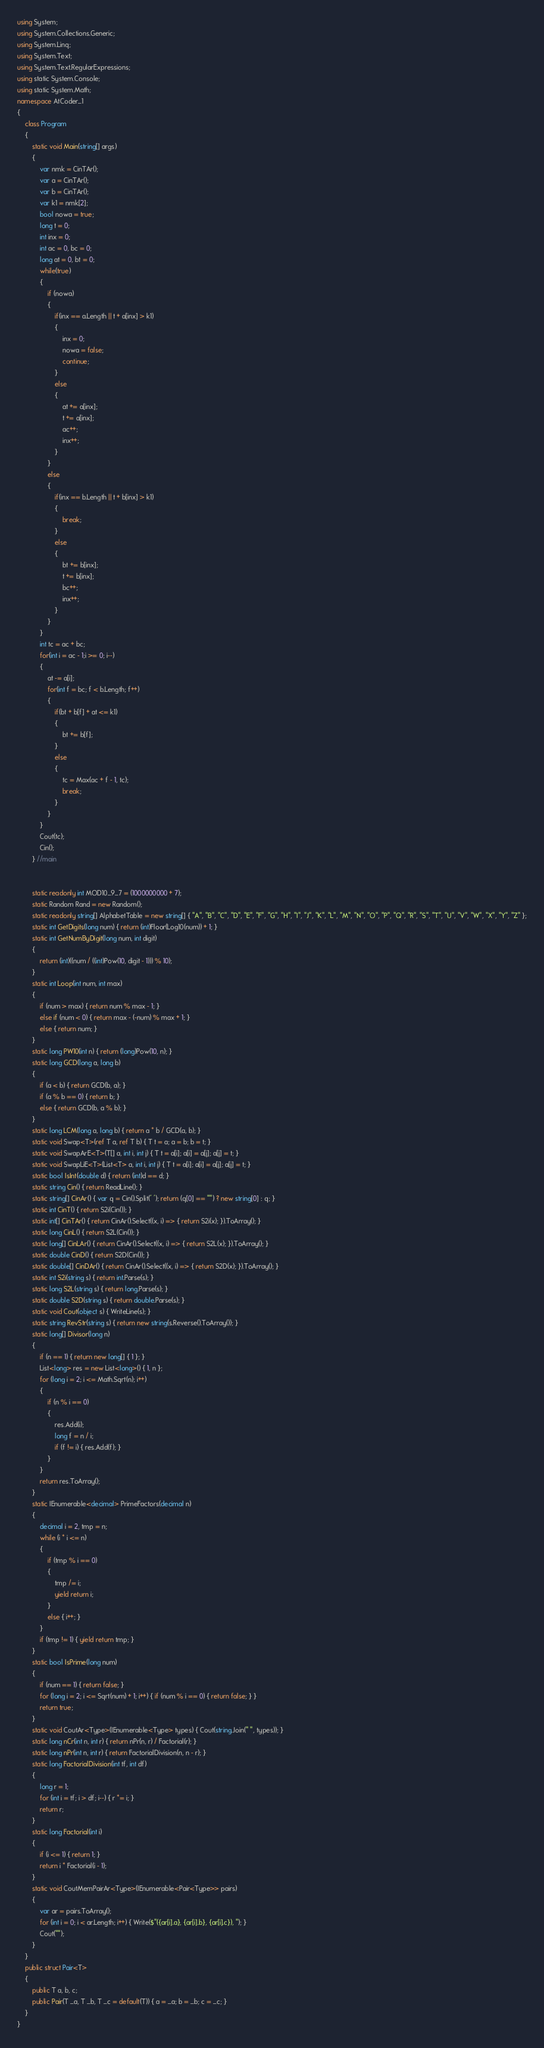Convert code to text. <code><loc_0><loc_0><loc_500><loc_500><_C#_>using System;
using System.Collections.Generic;
using System.Linq;
using System.Text;
using System.Text.RegularExpressions;
using static System.Console;
using static System.Math;
namespace AtCoder_1
{
    class Program
    {
        static void Main(string[] args)
        {
            var nmk = CinTAr();
            var a = CinTAr();
            var b = CinTAr();
            var k1 = nmk[2];
            bool nowa = true;
            long t = 0;
            int inx = 0;
            int ac = 0, bc = 0;
            long at = 0, bt = 0;
            while(true)
            {
                if (nowa)
                {
                    if(inx == a.Length || t + a[inx] > k1)
                    {
                        inx = 0;
                        nowa = false;
                        continue;
                    }
                    else
                    {
                        at += a[inx];
                        t += a[inx];
                        ac++;
                        inx++;
                    }
                }
                else
                {
                    if(inx == b.Length || t + b[inx] > k1)
                    {
                        break;
                    }
                    else
                    {
                        bt += b[inx];
                        t += b[inx];
                        bc++;
                        inx++;
                    }
                }
            }
            int tc = ac + bc;
            for(int i = ac - 1;i >= 0; i--)
            {
                at -= a[i];
                for(int f = bc; f < b.Length; f++)
                {
                    if(bt + b[f] + at <= k1)
                    {
                        bt += b[f];
                    }
                    else
                    {
                        tc = Max(ac + f - 1, tc);
                        break;
                    }
                }
            }
            Cout(tc);
            Cin();
        } //main


        static readonly int MOD10_9_7 = (1000000000 + 7);
        static Random Rand = new Random();
        static readonly string[] AlphabetTable = new string[] { "A", "B", "C", "D", "E", "F", "G", "H", "I", "J", "K", "L", "M", "N", "O", "P", "Q", "R", "S", "T", "U", "V", "W", "X", "Y", "Z" };
        static int GetDigits(long num) { return (int)Floor(Log10(num)) + 1; }
        static int GetNumByDigit(long num, int digit)
        {
            return (int)((num / ((int)Pow(10, digit - 1))) % 10);
        }
        static int Loop(int num, int max)
        {
            if (num > max) { return num % max - 1; }
            else if (num < 0) { return max - (-num) % max + 1; }
            else { return num; }
        }
        static long PW10(int n) { return (long)Pow(10, n); }
        static long GCD(long a, long b)
        {
            if (a < b) { return GCD(b, a); }
            if (a % b == 0) { return b; }
            else { return GCD(b, a % b); }
        }
        static long LCM(long a, long b) { return a * b / GCD(a, b); }
        static void Swap<T>(ref T a, ref T b) { T t = a; a = b; b = t; }
        static void SwapArE<T>(T[] a, int i, int j) { T t = a[i]; a[i] = a[j]; a[j] = t; }
        static void SwapLiE<T>(List<T> a, int i, int j) { T t = a[i]; a[i] = a[j]; a[j] = t; }
        static bool IsInt(double d) { return (int)d == d; }
        static string Cin() { return ReadLine(); }
        static string[] CinAr() { var q = Cin().Split(' '); return (q[0] == "") ? new string[0] : q; }
        static int CinT() { return S2i(Cin()); }
        static int[] CinTAr() { return CinAr().Select((x, i) => { return S2i(x); }).ToArray(); }
        static long CinL() { return S2L(Cin()); }
        static long[] CinLAr() { return CinAr().Select((x, i) => { return S2L(x); }).ToArray(); }
        static double CinD() { return S2D(Cin()); }
        static double[] CinDAr() { return CinAr().Select((x, i) => { return S2D(x); }).ToArray(); }
        static int S2i(string s) { return int.Parse(s); }
        static long S2L(string s) { return long.Parse(s); }
        static double S2D(string s) { return double.Parse(s); }
        static void Cout(object s) { WriteLine(s); }
        static string RevStr(string s) { return new string(s.Reverse().ToArray()); }
        static long[] Divisor(long n)
        {
            if (n == 1) { return new long[] { 1 }; }
            List<long> res = new List<long>() { 1, n };
            for (long i = 2; i <= Math.Sqrt(n); i++)
            {
                if (n % i == 0)
                {
                    res.Add(i);
                    long f = n / i;
                    if (f != i) { res.Add(f); }
                }
            }
            return res.ToArray();
        }
        static IEnumerable<decimal> PrimeFactors(decimal n)
        {
            decimal i = 2, tmp = n;
            while (i * i <= n)
            {
                if (tmp % i == 0)
                {
                    tmp /= i;
                    yield return i;
                }
                else { i++; }
            }
            if (tmp != 1) { yield return tmp; }
        }
        static bool IsPrime(long num)
        {
            if (num == 1) { return false; }
            for (long i = 2; i <= Sqrt(num) + 1; i++) { if (num % i == 0) { return false; } }
            return true;
        }
        static void CoutAr<Type>(IEnumerable<Type> types) { Cout(string.Join(" ", types)); }
        static long nCr(int n, int r) { return nPr(n, r) / Factorial(r); }
        static long nPr(int n, int r) { return FactorialDivision(n, n - r); }
        static long FactorialDivision(int tf, int df)
        {
            long r = 1;
            for (int i = tf; i > df; i--) { r *= i; }
            return r;
        }
        static long Factorial(int i)
        {
            if (i <= 1) { return 1; }
            return i * Factorial(i - 1);
        }
        static void CoutMemPairAr<Type>(IEnumerable<Pair<Type>> pairs)
        {
            var ar = pairs.ToArray();
            for (int i = 0; i < ar.Length; i++) { Write($"({ar[i].a}, {ar[i].b}, {ar[i].c}), "); }
            Cout("");
        }
    }
    public struct Pair<T>
    {
        public T a, b, c;
        public Pair(T _a, T _b, T _c = default(T)) { a = _a; b = _b; c = _c; }
    }
}
</code> 